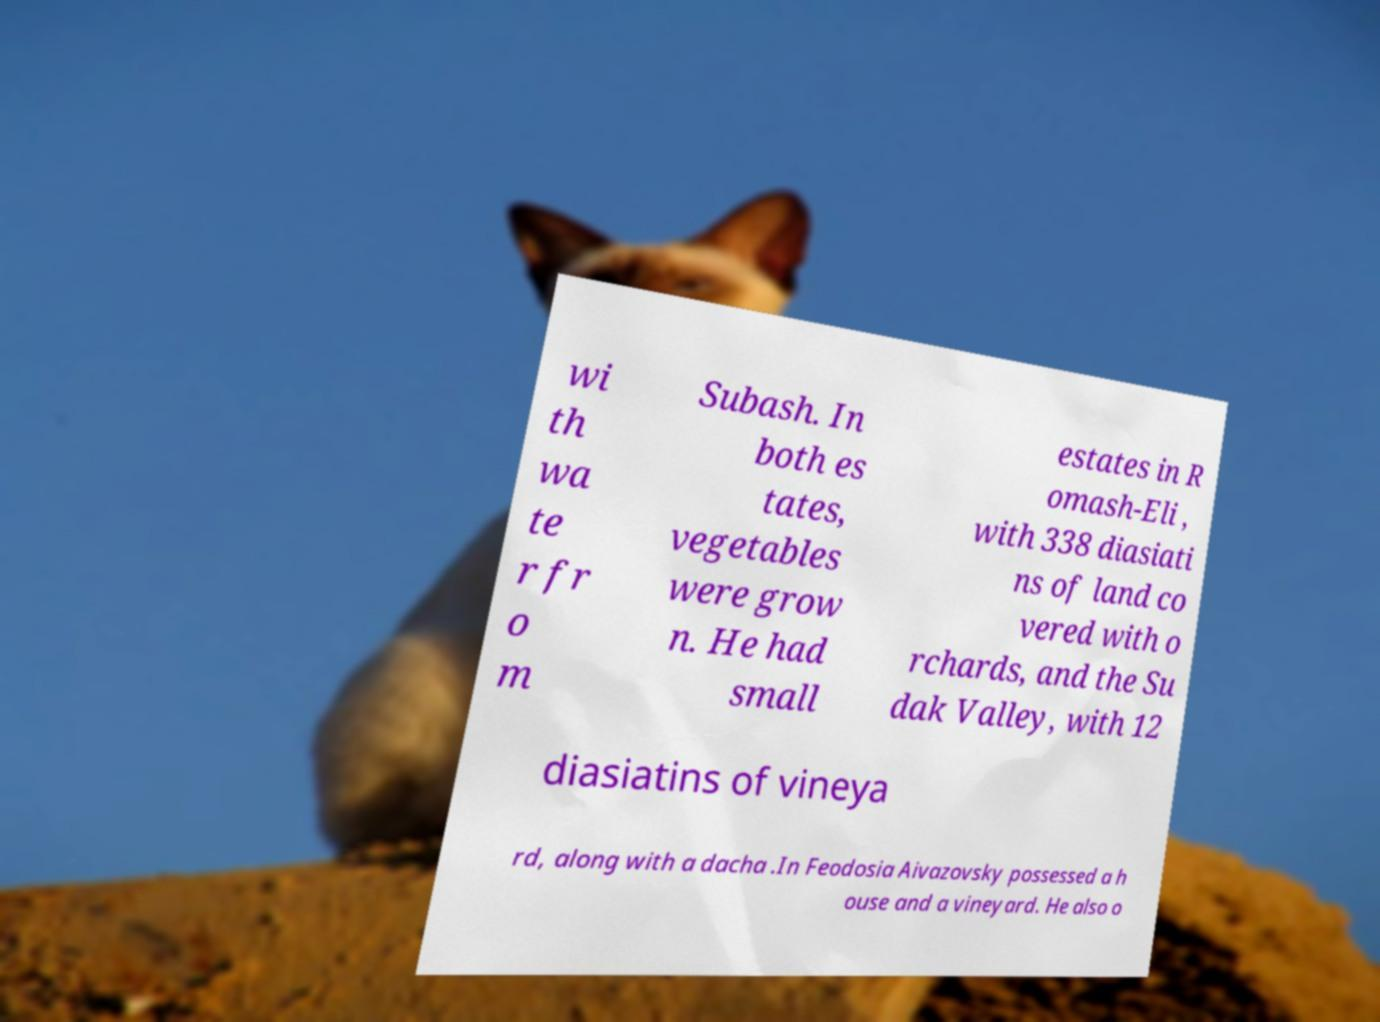Please read and relay the text visible in this image. What does it say? wi th wa te r fr o m Subash. In both es tates, vegetables were grow n. He had small estates in R omash-Eli , with 338 diasiati ns of land co vered with o rchards, and the Su dak Valley, with 12 diasiatins of vineya rd, along with a dacha .In Feodosia Aivazovsky possessed a h ouse and a vineyard. He also o 